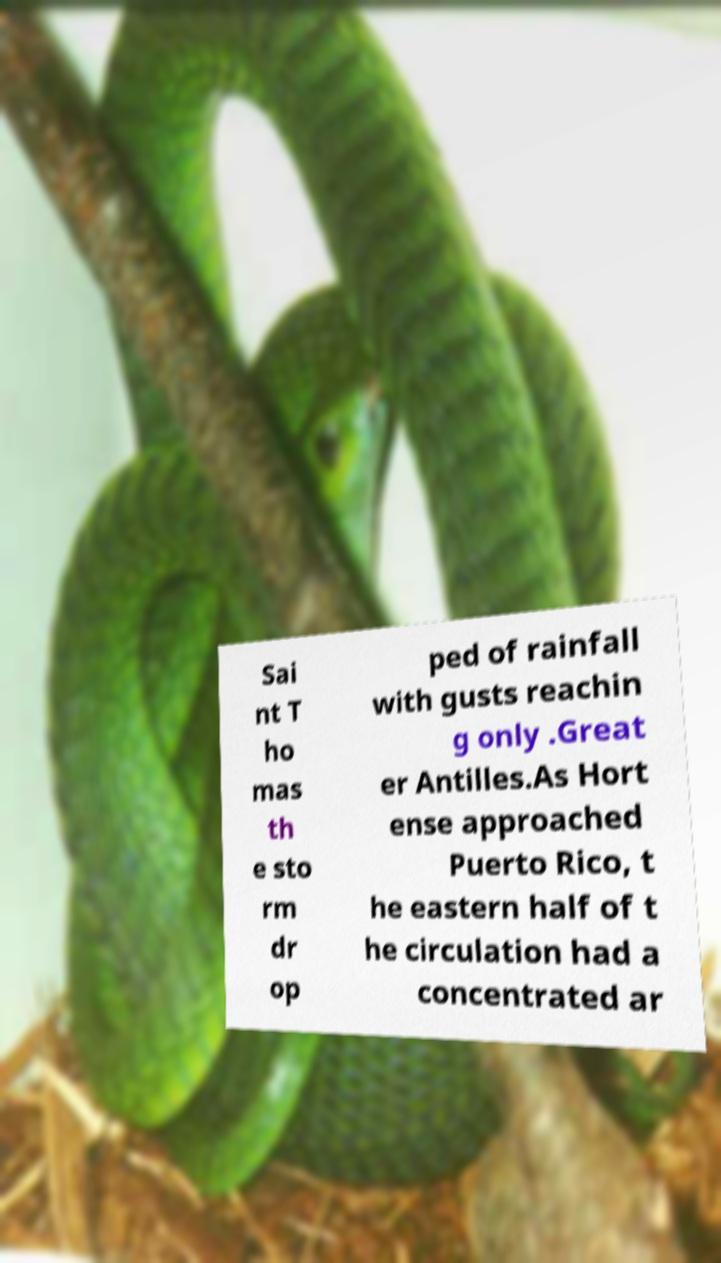For documentation purposes, I need the text within this image transcribed. Could you provide that? Sai nt T ho mas th e sto rm dr op ped of rainfall with gusts reachin g only .Great er Antilles.As Hort ense approached Puerto Rico, t he eastern half of t he circulation had a concentrated ar 